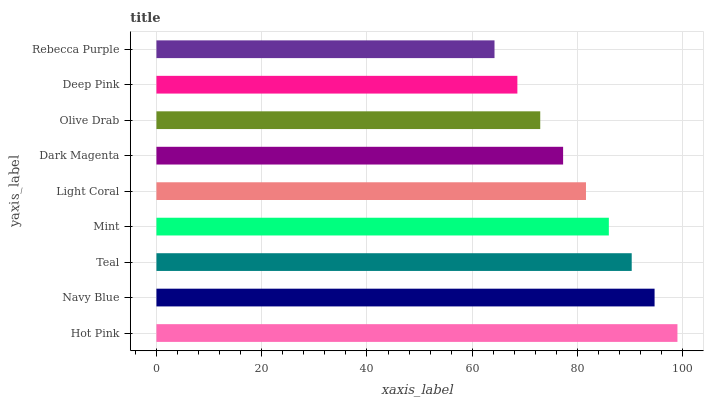Is Rebecca Purple the minimum?
Answer yes or no. Yes. Is Hot Pink the maximum?
Answer yes or no. Yes. Is Navy Blue the minimum?
Answer yes or no. No. Is Navy Blue the maximum?
Answer yes or no. No. Is Hot Pink greater than Navy Blue?
Answer yes or no. Yes. Is Navy Blue less than Hot Pink?
Answer yes or no. Yes. Is Navy Blue greater than Hot Pink?
Answer yes or no. No. Is Hot Pink less than Navy Blue?
Answer yes or no. No. Is Light Coral the high median?
Answer yes or no. Yes. Is Light Coral the low median?
Answer yes or no. Yes. Is Navy Blue the high median?
Answer yes or no. No. Is Navy Blue the low median?
Answer yes or no. No. 